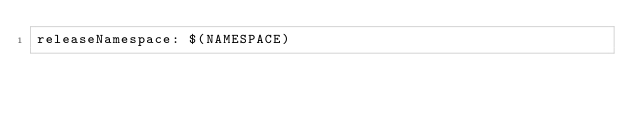Convert code to text. <code><loc_0><loc_0><loc_500><loc_500><_YAML_>releaseNamespace: $(NAMESPACE)
</code> 